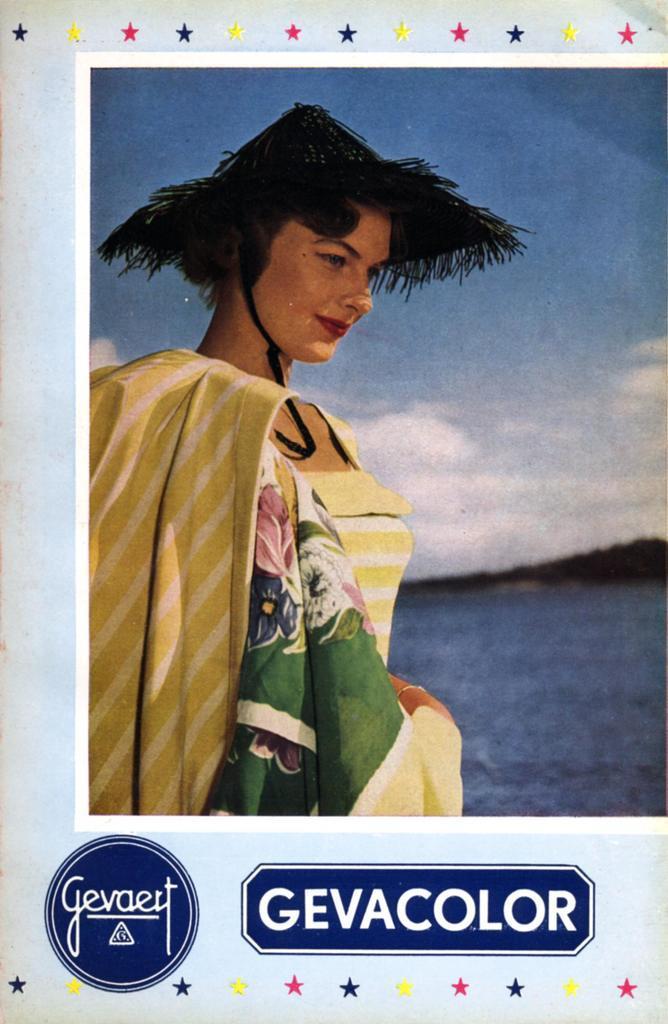Please provide a concise description of this image. In the picture we can see a photograph of a woman with different costume and beside her we can see the water, which is blue in color and far away from it, we can see hills and sky with clouds and below it we can see a name gevacolor. 